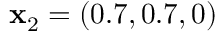<formula> <loc_0><loc_0><loc_500><loc_500>x _ { 2 } = ( 0 . 7 , 0 . 7 , 0 )</formula> 